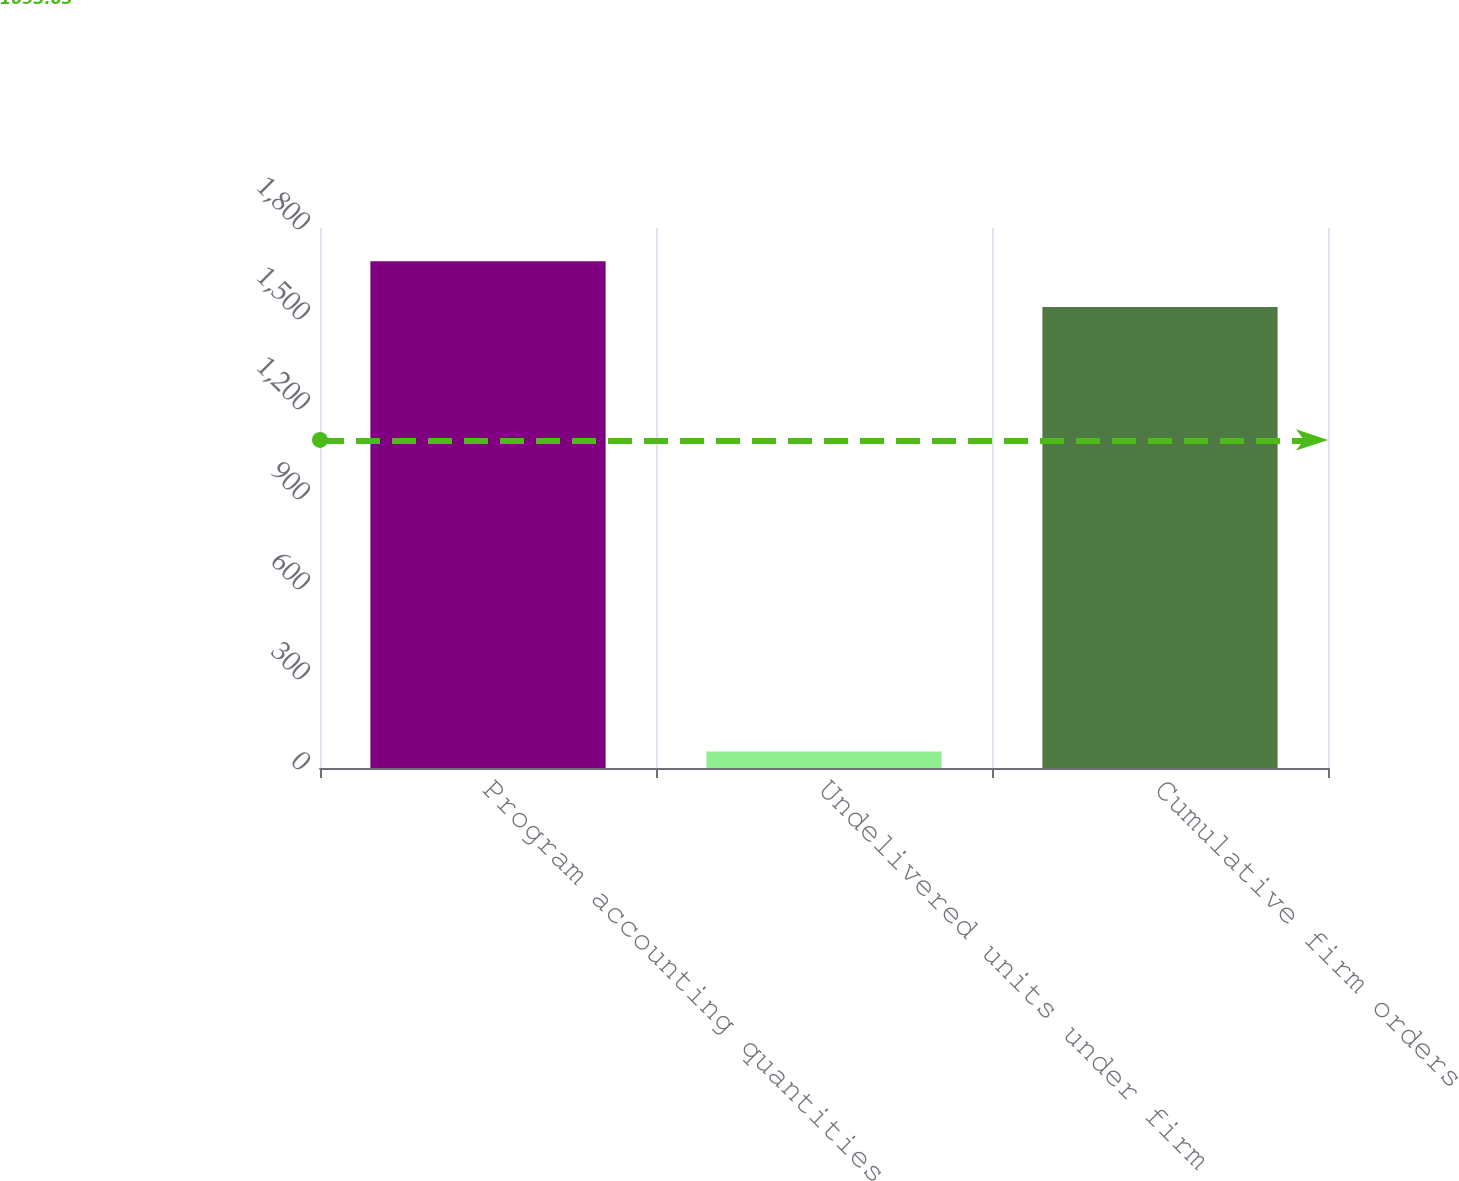Convert chart to OTSL. <chart><loc_0><loc_0><loc_500><loc_500><bar_chart><fcel>Program accounting quantities<fcel>Undelivered units under firm<fcel>Cumulative firm orders<nl><fcel>1688.9<fcel>55<fcel>1537<nl></chart> 